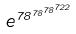Convert formula to latex. <formula><loc_0><loc_0><loc_500><loc_500>e ^ { 7 8 ^ { 7 8 ^ { 7 8 ^ { 7 2 2 } } } }</formula> 